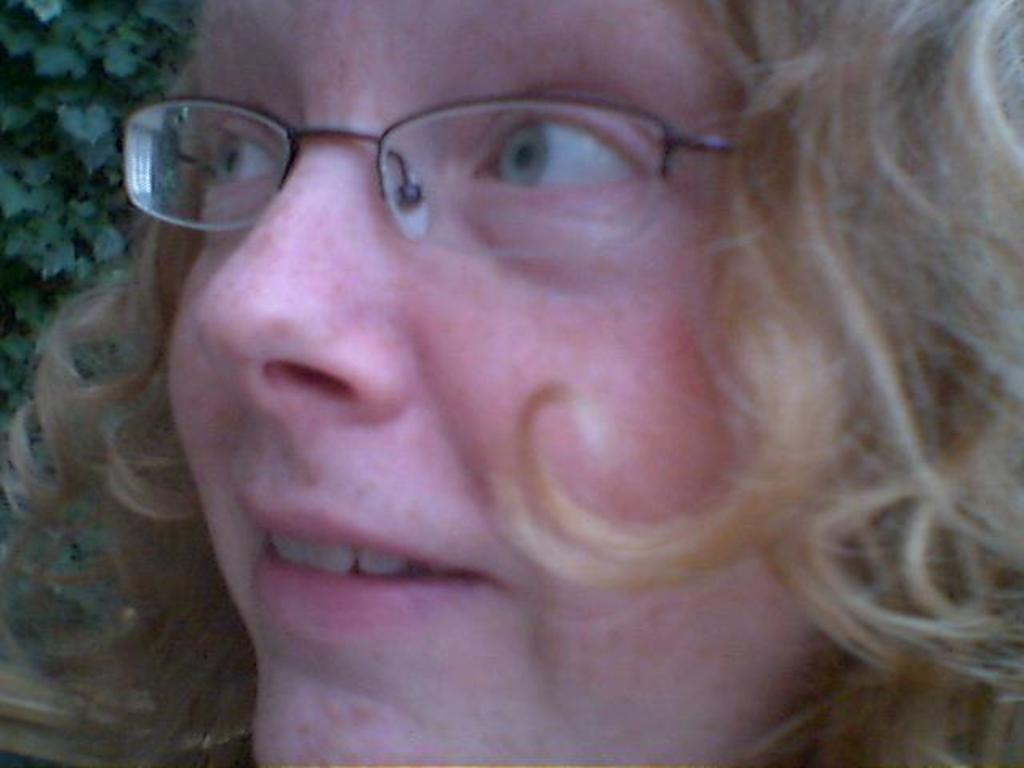Who is present in the image? There is a woman in the image. What can be observed about the woman's appearance? The woman is wearing spectacles and has cream-colored hair. What can be seen in the background of the image? There are leaves in the background of the image. What type of ear is visible on the woman in the image? There is no ear visible on the woman in the image; only her face, hair, and spectacles can be seen. 